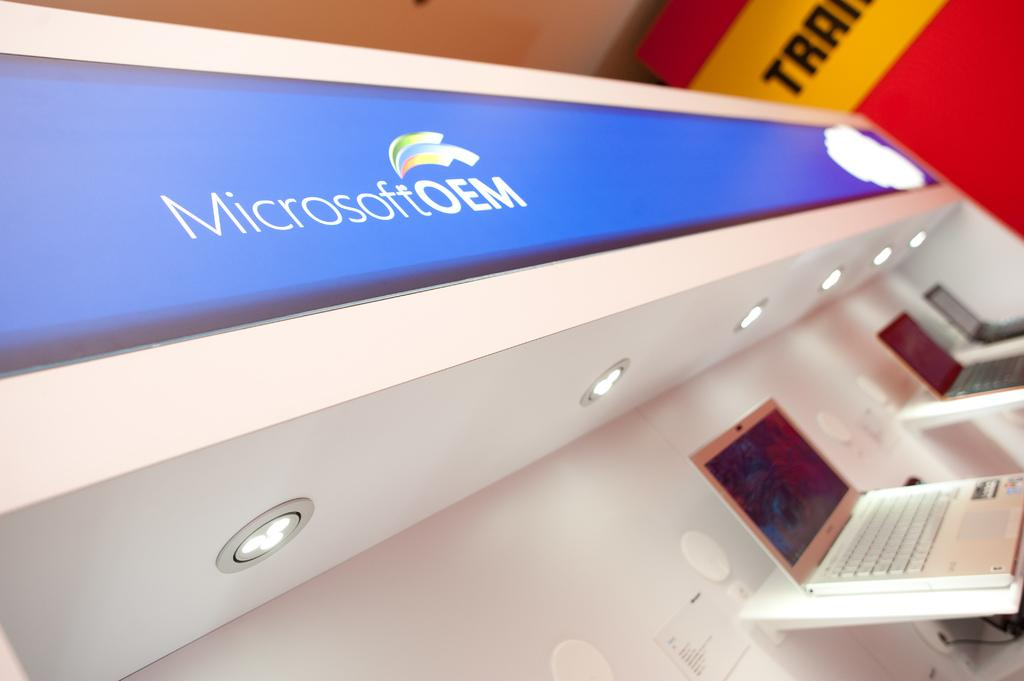<image>
Describe the image concisely. A display of different laptops under a Microsoft sign. 